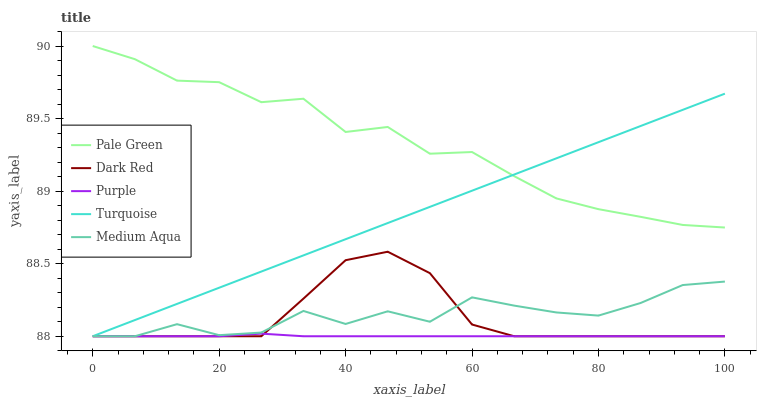Does Purple have the minimum area under the curve?
Answer yes or no. Yes. Does Pale Green have the maximum area under the curve?
Answer yes or no. Yes. Does Dark Red have the minimum area under the curve?
Answer yes or no. No. Does Dark Red have the maximum area under the curve?
Answer yes or no. No. Is Turquoise the smoothest?
Answer yes or no. Yes. Is Medium Aqua the roughest?
Answer yes or no. Yes. Is Dark Red the smoothest?
Answer yes or no. No. Is Dark Red the roughest?
Answer yes or no. No. Does Purple have the lowest value?
Answer yes or no. Yes. Does Pale Green have the lowest value?
Answer yes or no. No. Does Pale Green have the highest value?
Answer yes or no. Yes. Does Dark Red have the highest value?
Answer yes or no. No. Is Purple less than Pale Green?
Answer yes or no. Yes. Is Pale Green greater than Dark Red?
Answer yes or no. Yes. Does Turquoise intersect Pale Green?
Answer yes or no. Yes. Is Turquoise less than Pale Green?
Answer yes or no. No. Is Turquoise greater than Pale Green?
Answer yes or no. No. Does Purple intersect Pale Green?
Answer yes or no. No. 